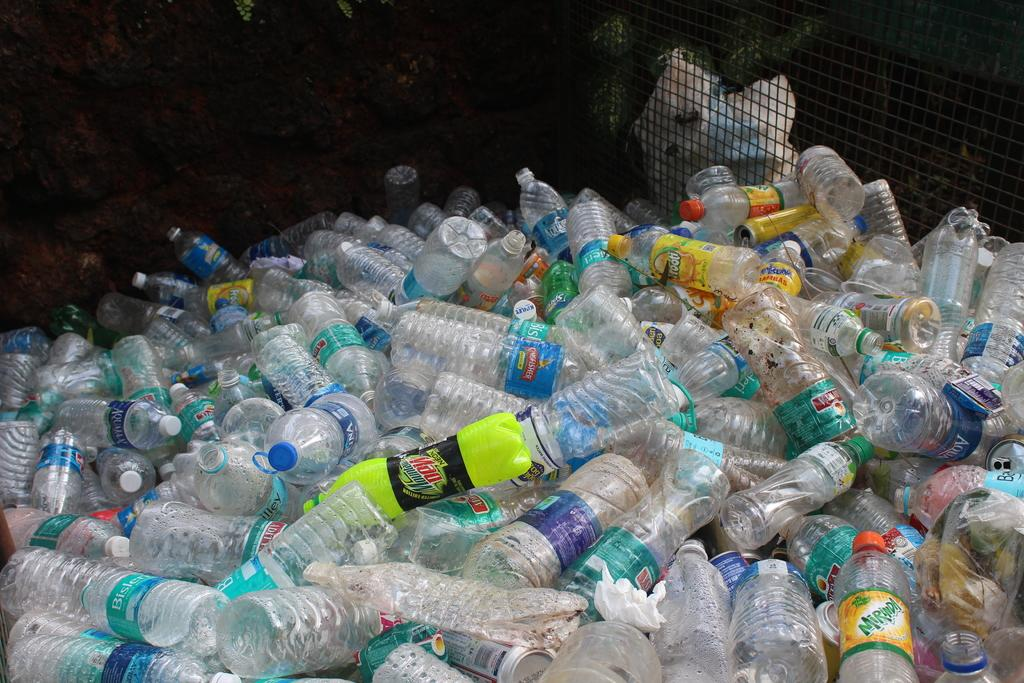<image>
Share a concise interpretation of the image provided. Plastic bottles are in a pile with some labeled Mt Dew. 